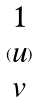<formula> <loc_0><loc_0><loc_500><loc_500>( \begin{matrix} 1 \\ u \\ v \end{matrix} )</formula> 